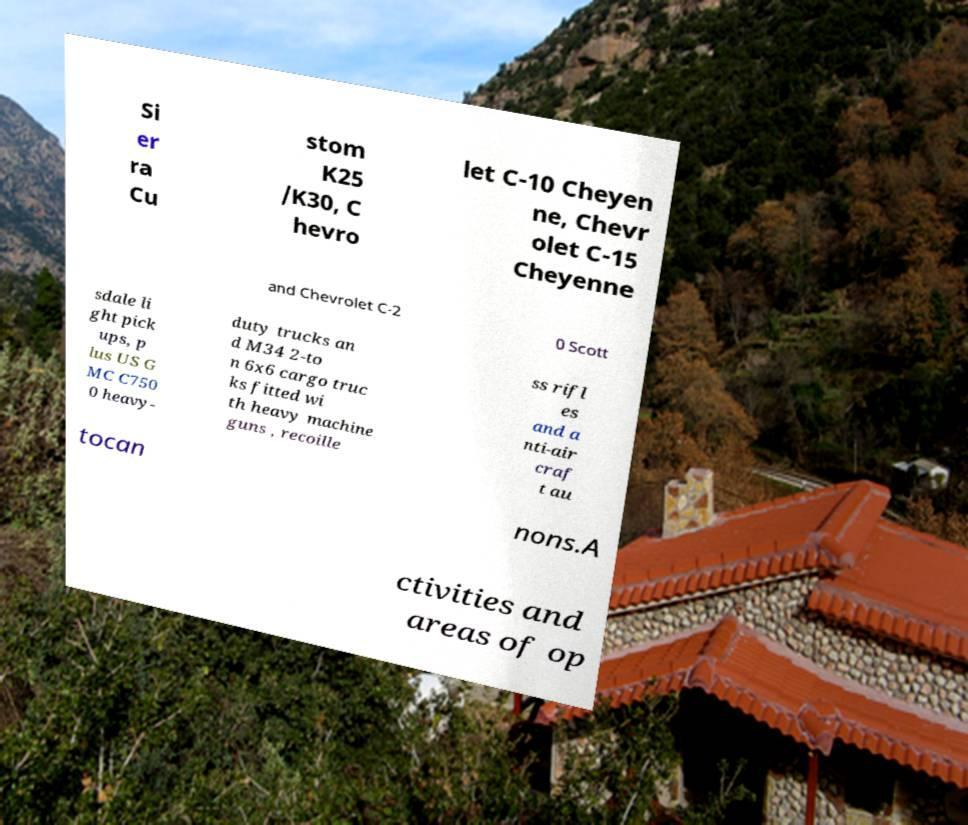Could you extract and type out the text from this image? Si er ra Cu stom K25 /K30, C hevro let C-10 Cheyen ne, Chevr olet C-15 Cheyenne and Chevrolet C-2 0 Scott sdale li ght pick ups, p lus US G MC C750 0 heavy- duty trucks an d M34 2-to n 6x6 cargo truc ks fitted wi th heavy machine guns , recoille ss rifl es and a nti-air craf t au tocan nons.A ctivities and areas of op 